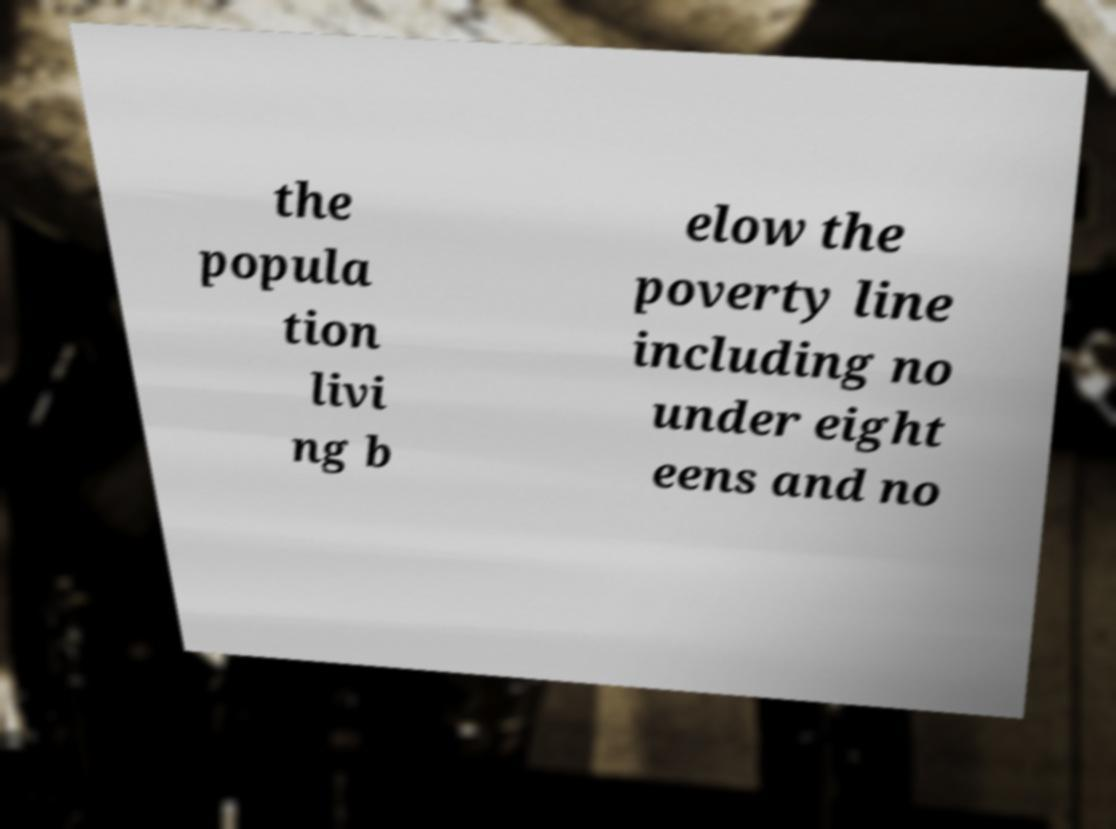There's text embedded in this image that I need extracted. Can you transcribe it verbatim? the popula tion livi ng b elow the poverty line including no under eight eens and no 